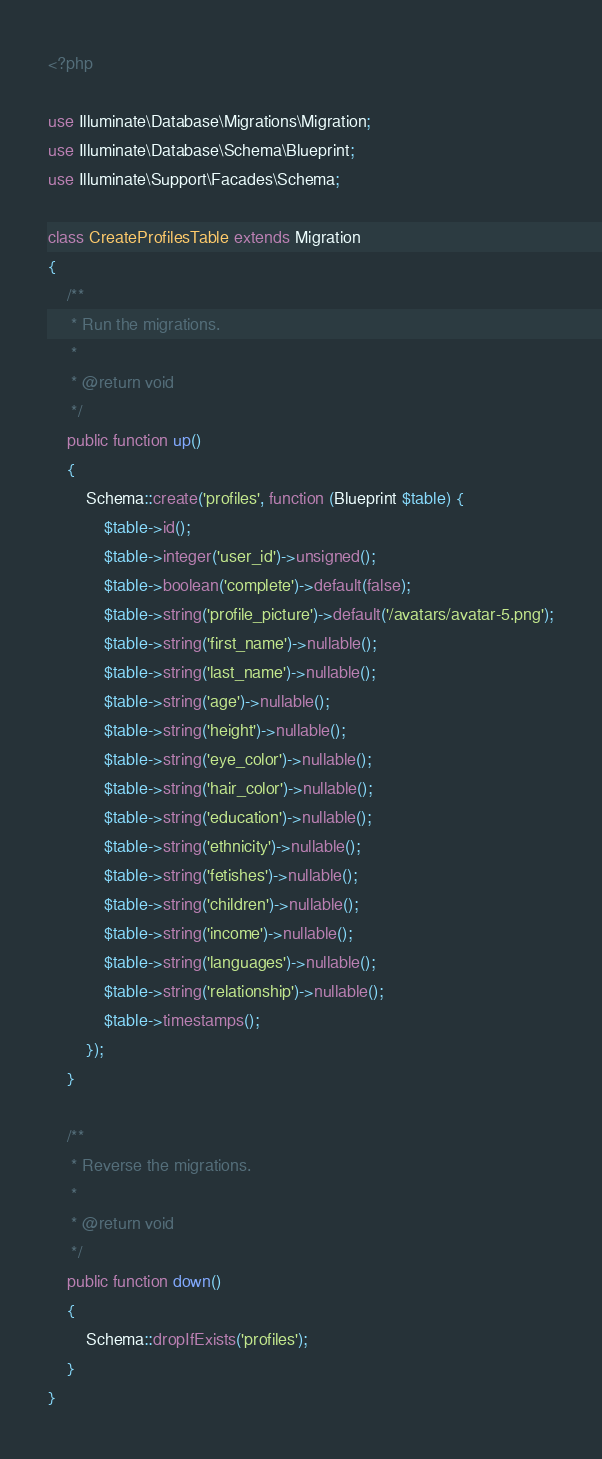<code> <loc_0><loc_0><loc_500><loc_500><_PHP_><?php

use Illuminate\Database\Migrations\Migration;
use Illuminate\Database\Schema\Blueprint;
use Illuminate\Support\Facades\Schema;

class CreateProfilesTable extends Migration
{
    /**
     * Run the migrations.
     *
     * @return void
     */
    public function up()
    {
        Schema::create('profiles', function (Blueprint $table) {
            $table->id();
            $table->integer('user_id')->unsigned();
            $table->boolean('complete')->default(false);
            $table->string('profile_picture')->default('/avatars/avatar-5.png');
            $table->string('first_name')->nullable();
            $table->string('last_name')->nullable();
            $table->string('age')->nullable();
            $table->string('height')->nullable();
            $table->string('eye_color')->nullable();
            $table->string('hair_color')->nullable();
            $table->string('education')->nullable();
            $table->string('ethnicity')->nullable();
            $table->string('fetishes')->nullable();
            $table->string('children')->nullable();
            $table->string('income')->nullable();
            $table->string('languages')->nullable();
            $table->string('relationship')->nullable();
            $table->timestamps();
        });
    }

    /**
     * Reverse the migrations.
     *
     * @return void
     */
    public function down()
    {
        Schema::dropIfExists('profiles');
    }
}
</code> 